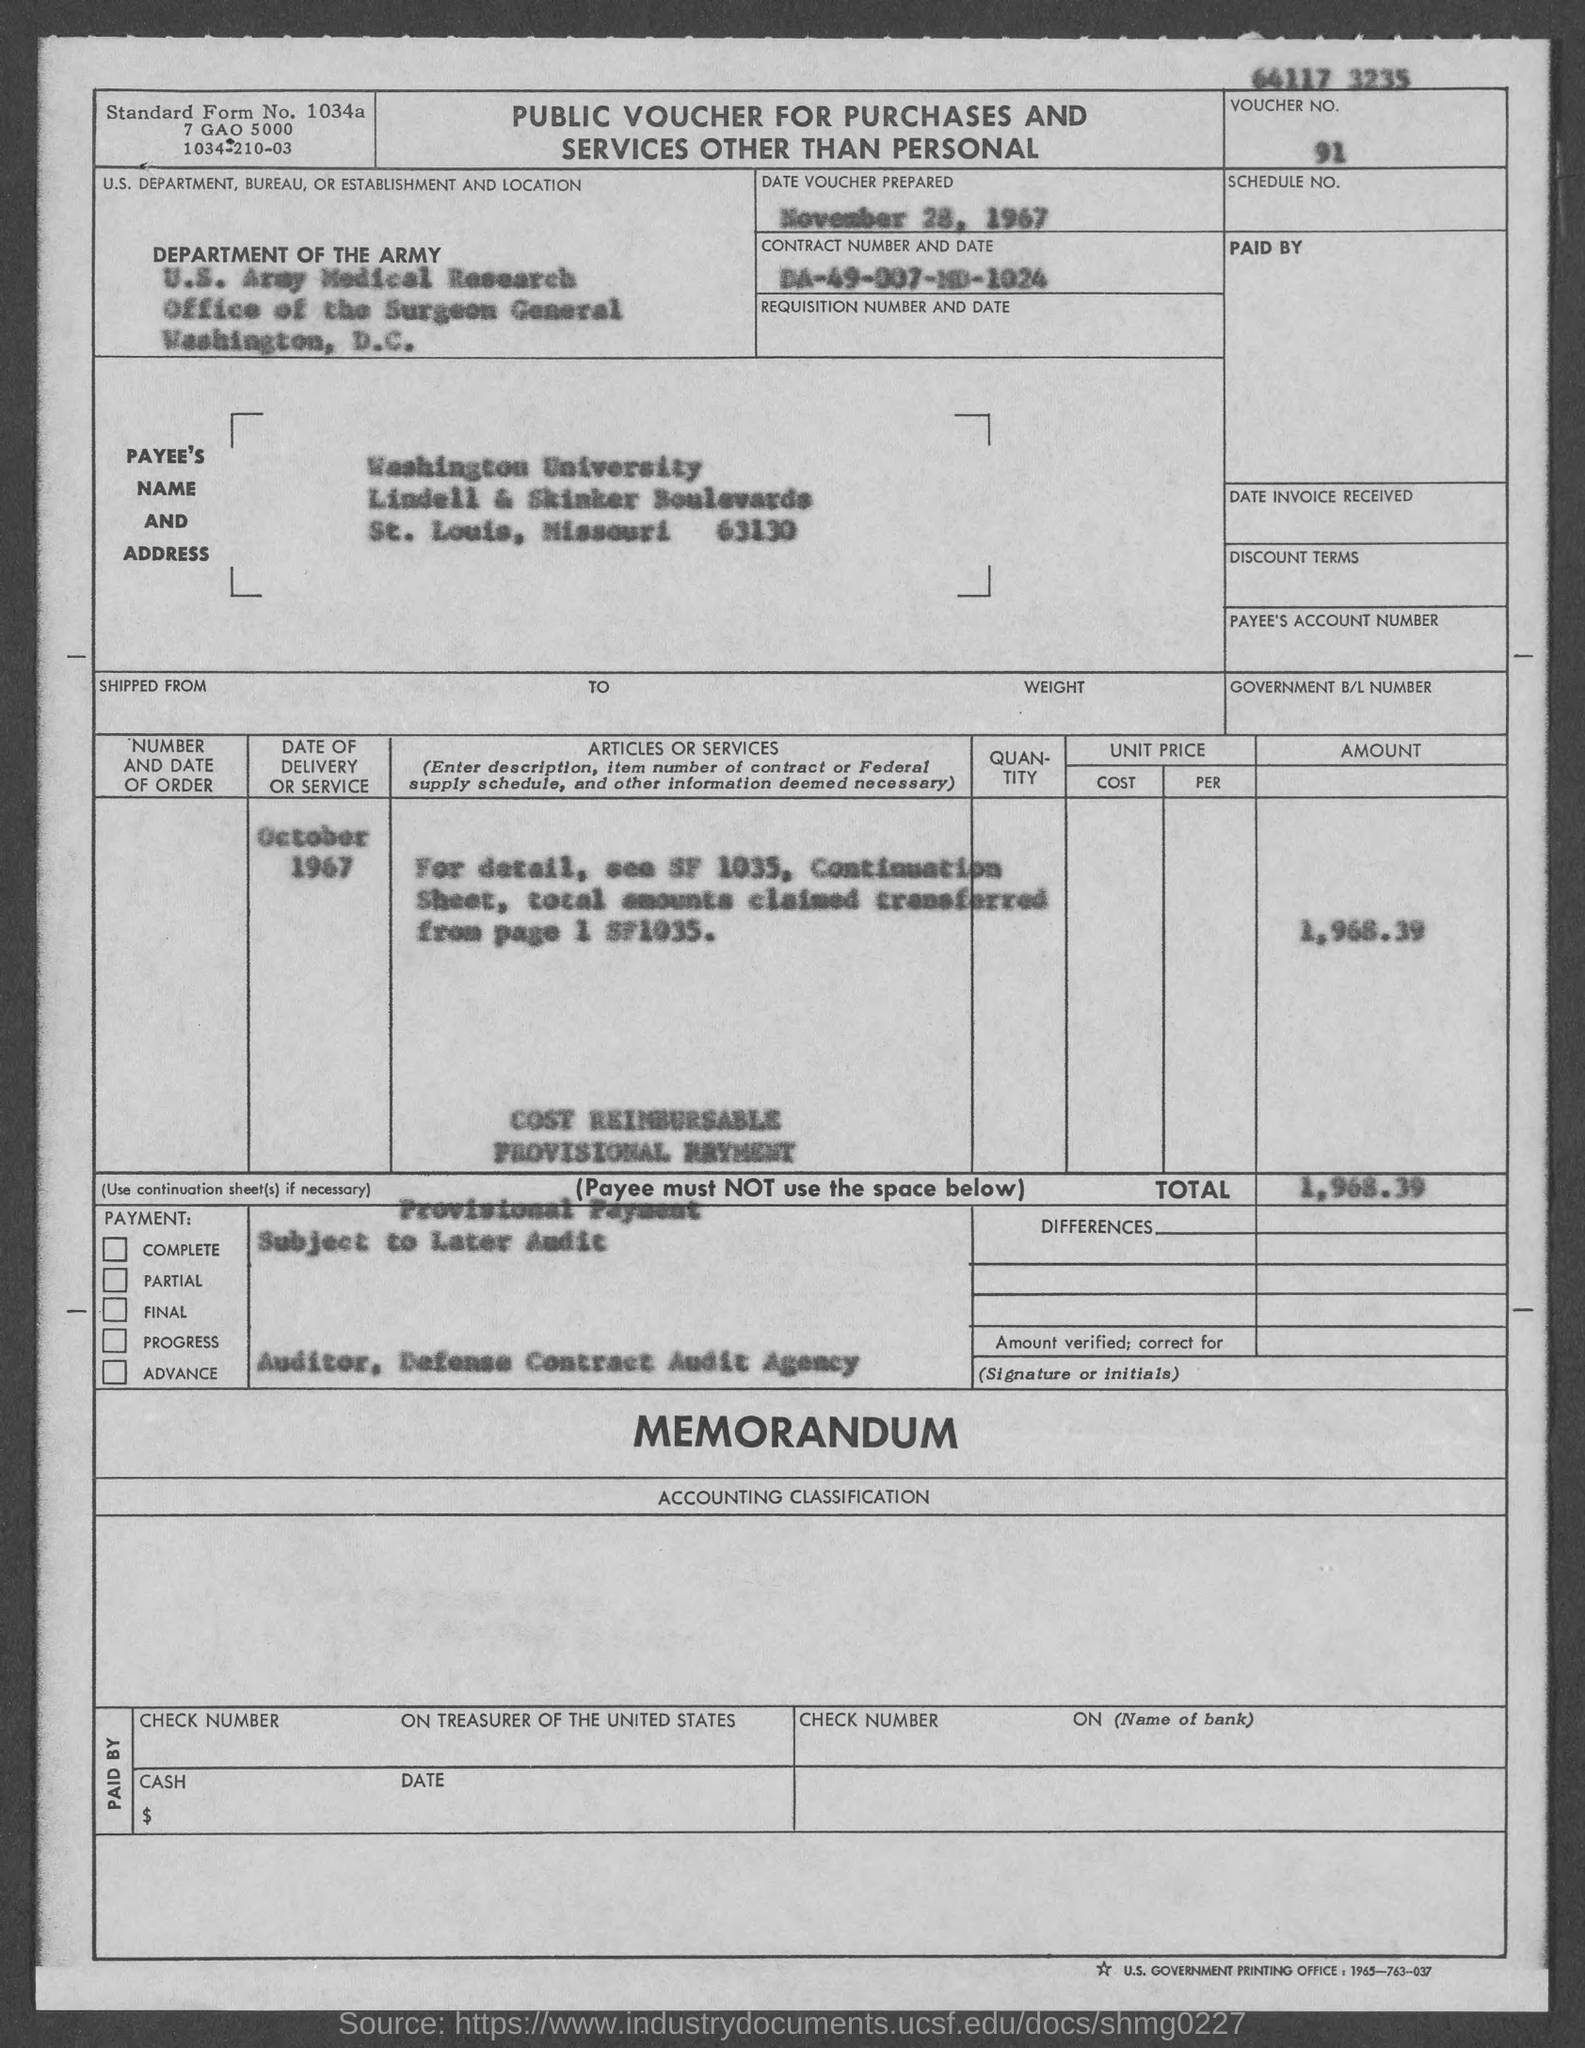List a handful of essential elements in this visual. The contract number is DA-49-007-MD-1024. The voucher number is 91... The Office of the Surgeon General is located in the city of Washington. What is the standard form number? The voucher was prepared on November 28, 1967. 